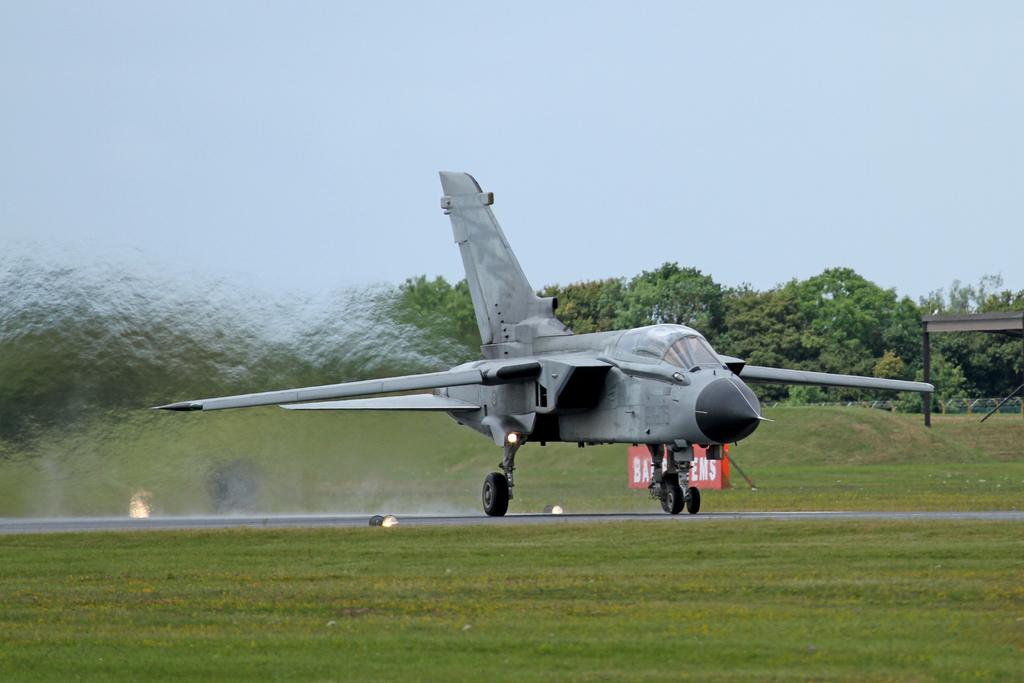What can be seen in the sky in the image? The sky is visible in the image. What type of vegetation is present in the image? There are trees and grass in the image. What type of vehicle is in the image? There is a fighter aircraft in the image. What is written or displayed on a board in the image? There is text on a board in the image. What type of illumination is present on the ground in the image? There are lights on the ground in the image. What is the tendency of the coast in the image? There is no coast present in the image, so it is not possible to determine its tendency. What is the argument between the trees in the image? There is no argument between the trees in the image, as trees do not engage in arguments. 